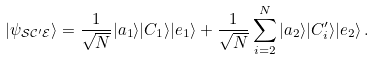<formula> <loc_0><loc_0><loc_500><loc_500>| \psi _ { \mathcal { S C ^ { \prime } E } } \rangle = \frac { 1 } { \sqrt { N } } | a _ { 1 } \rangle | C _ { 1 } \rangle | e _ { 1 } \rangle + \frac { 1 } { \sqrt { N } } \sum ^ { N } _ { i = 2 } | a _ { 2 } \rangle | C ^ { \prime } _ { i } \rangle | e _ { 2 } \rangle \, .</formula> 